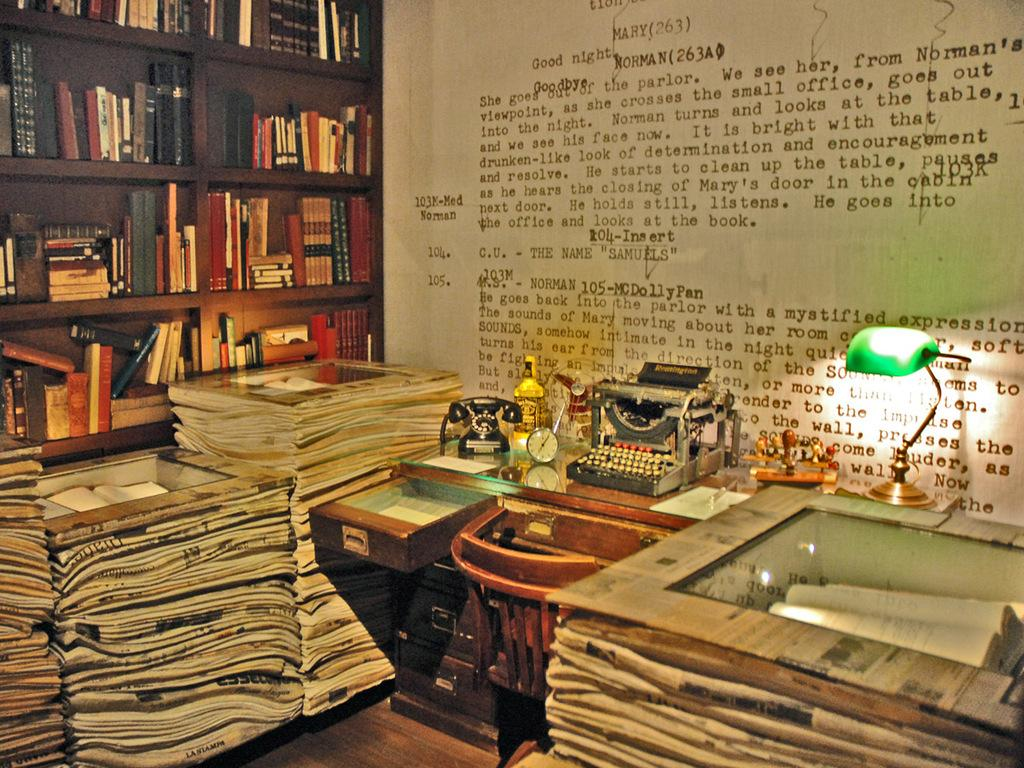<image>
Share a concise interpretation of the image provided. an office packed with maggazine books and writing on the wall with the words good night at the type 